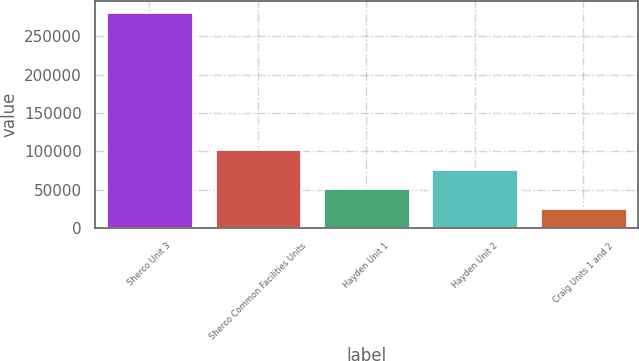Convert chart to OTSL. <chart><loc_0><loc_0><loc_500><loc_500><bar_chart><fcel>Sherco Unit 3<fcel>Sherco Common Facilities Units<fcel>Hayden Unit 1<fcel>Hayden Unit 2<fcel>Craig Units 1 and 2<nl><fcel>282145<fcel>103066<fcel>51900.7<fcel>77483.4<fcel>26318<nl></chart> 